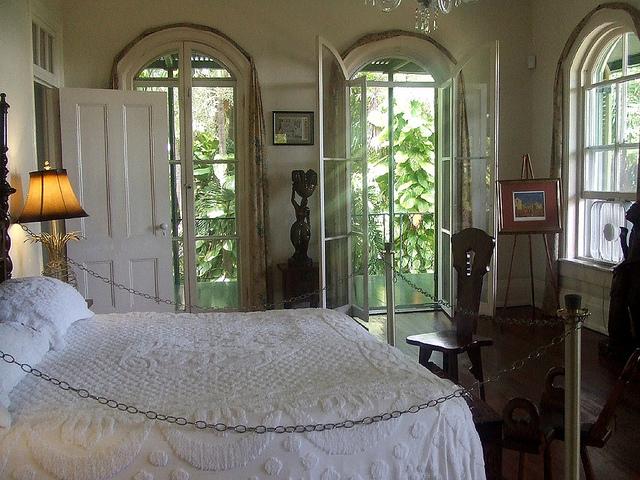Does anyone use the bed?
Write a very short answer. No. Is there a phone in the room?
Write a very short answer. No. What color is the bedspread?
Short answer required. White. Are there humans in this photo?
Keep it brief. No. Is there something unusual surrounding the bed?
Quick response, please. Yes. 